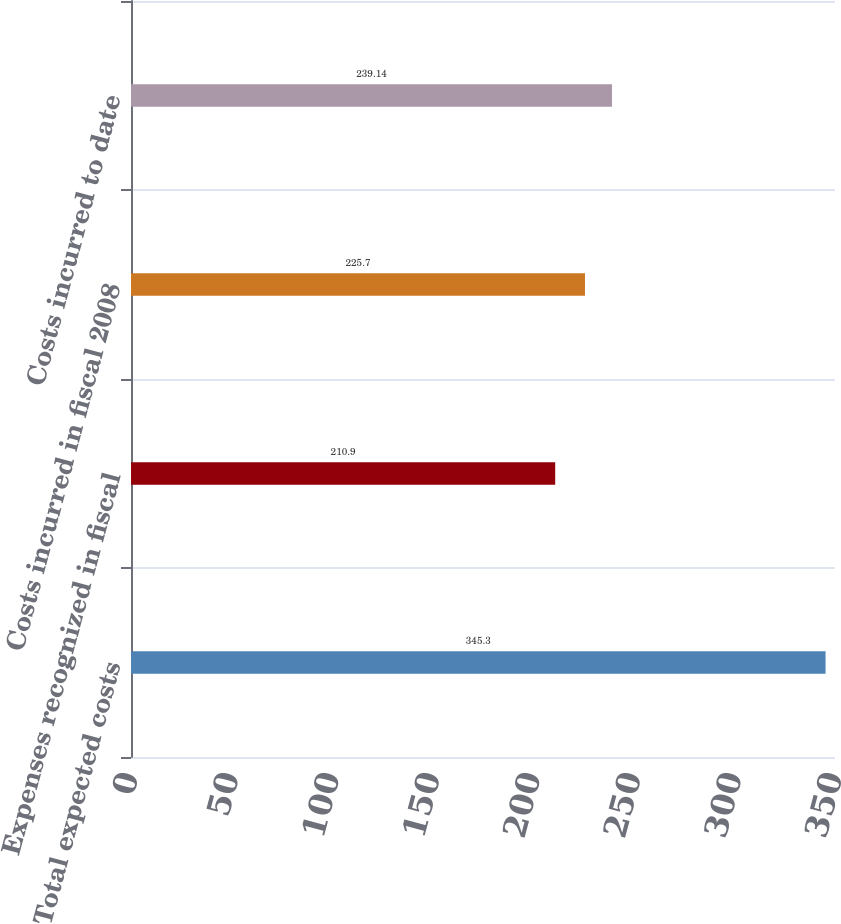Convert chart to OTSL. <chart><loc_0><loc_0><loc_500><loc_500><bar_chart><fcel>Total expected costs<fcel>Expenses recognized in fiscal<fcel>Costs incurred in fiscal 2008<fcel>Costs incurred to date<nl><fcel>345.3<fcel>210.9<fcel>225.7<fcel>239.14<nl></chart> 